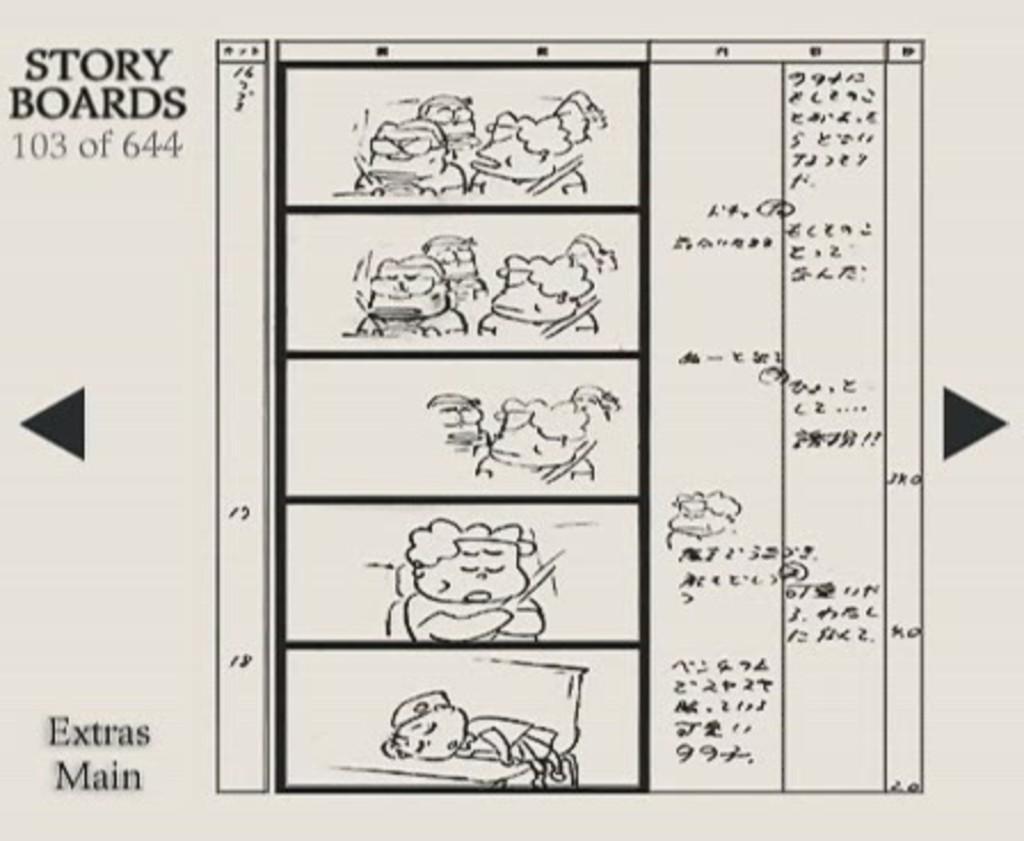In one or two sentences, can you explain what this image depicts? In this image I can see some text and few cartoon images on a white paper. 